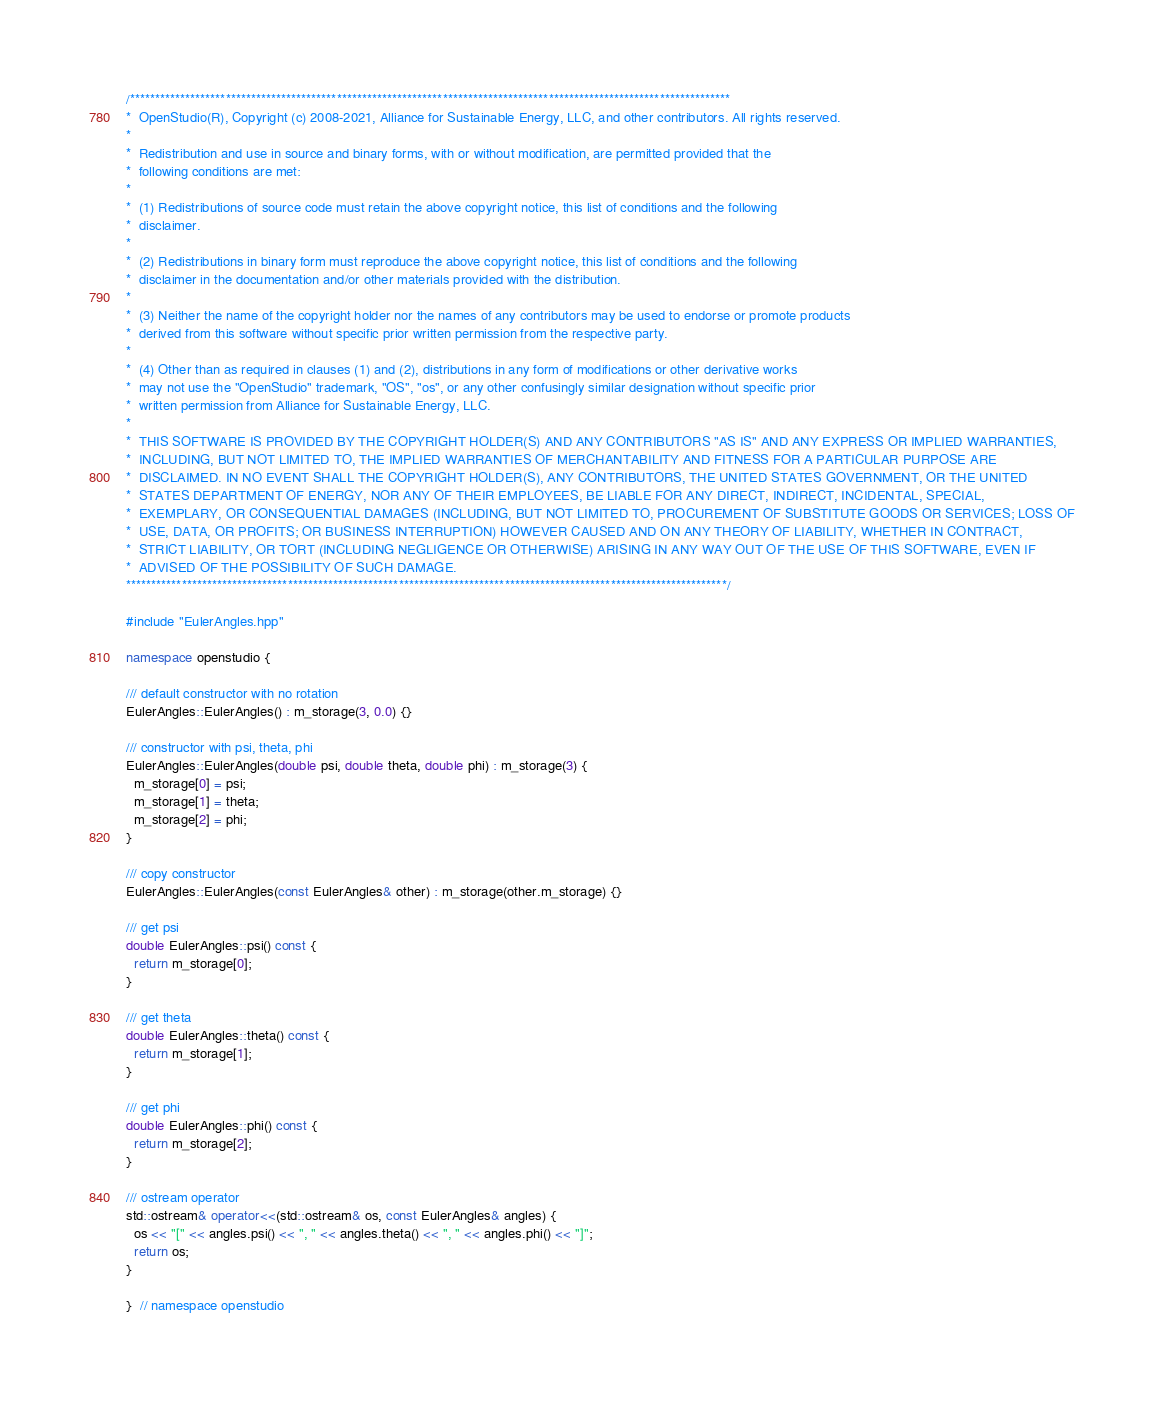<code> <loc_0><loc_0><loc_500><loc_500><_C++_>/***********************************************************************************************************************
*  OpenStudio(R), Copyright (c) 2008-2021, Alliance for Sustainable Energy, LLC, and other contributors. All rights reserved.
*
*  Redistribution and use in source and binary forms, with or without modification, are permitted provided that the
*  following conditions are met:
*
*  (1) Redistributions of source code must retain the above copyright notice, this list of conditions and the following
*  disclaimer.
*
*  (2) Redistributions in binary form must reproduce the above copyright notice, this list of conditions and the following
*  disclaimer in the documentation and/or other materials provided with the distribution.
*
*  (3) Neither the name of the copyright holder nor the names of any contributors may be used to endorse or promote products
*  derived from this software without specific prior written permission from the respective party.
*
*  (4) Other than as required in clauses (1) and (2), distributions in any form of modifications or other derivative works
*  may not use the "OpenStudio" trademark, "OS", "os", or any other confusingly similar designation without specific prior
*  written permission from Alliance for Sustainable Energy, LLC.
*
*  THIS SOFTWARE IS PROVIDED BY THE COPYRIGHT HOLDER(S) AND ANY CONTRIBUTORS "AS IS" AND ANY EXPRESS OR IMPLIED WARRANTIES,
*  INCLUDING, BUT NOT LIMITED TO, THE IMPLIED WARRANTIES OF MERCHANTABILITY AND FITNESS FOR A PARTICULAR PURPOSE ARE
*  DISCLAIMED. IN NO EVENT SHALL THE COPYRIGHT HOLDER(S), ANY CONTRIBUTORS, THE UNITED STATES GOVERNMENT, OR THE UNITED
*  STATES DEPARTMENT OF ENERGY, NOR ANY OF THEIR EMPLOYEES, BE LIABLE FOR ANY DIRECT, INDIRECT, INCIDENTAL, SPECIAL,
*  EXEMPLARY, OR CONSEQUENTIAL DAMAGES (INCLUDING, BUT NOT LIMITED TO, PROCUREMENT OF SUBSTITUTE GOODS OR SERVICES; LOSS OF
*  USE, DATA, OR PROFITS; OR BUSINESS INTERRUPTION) HOWEVER CAUSED AND ON ANY THEORY OF LIABILITY, WHETHER IN CONTRACT,
*  STRICT LIABILITY, OR TORT (INCLUDING NEGLIGENCE OR OTHERWISE) ARISING IN ANY WAY OUT OF THE USE OF THIS SOFTWARE, EVEN IF
*  ADVISED OF THE POSSIBILITY OF SUCH DAMAGE.
***********************************************************************************************************************/

#include "EulerAngles.hpp"

namespace openstudio {

/// default constructor with no rotation
EulerAngles::EulerAngles() : m_storage(3, 0.0) {}

/// constructor with psi, theta, phi
EulerAngles::EulerAngles(double psi, double theta, double phi) : m_storage(3) {
  m_storage[0] = psi;
  m_storage[1] = theta;
  m_storage[2] = phi;
}

/// copy constructor
EulerAngles::EulerAngles(const EulerAngles& other) : m_storage(other.m_storage) {}

/// get psi
double EulerAngles::psi() const {
  return m_storage[0];
}

/// get theta
double EulerAngles::theta() const {
  return m_storage[1];
}

/// get phi
double EulerAngles::phi() const {
  return m_storage[2];
}

/// ostream operator
std::ostream& operator<<(std::ostream& os, const EulerAngles& angles) {
  os << "[" << angles.psi() << ", " << angles.theta() << ", " << angles.phi() << "]";
  return os;
}

}  // namespace openstudio
</code> 